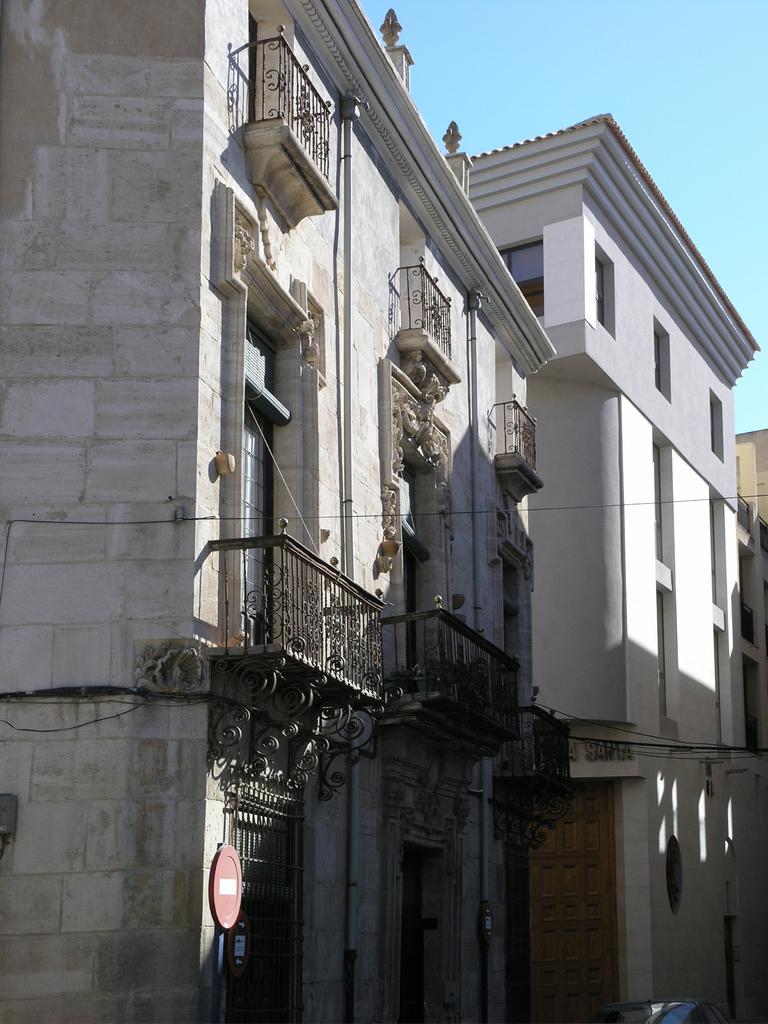How would you summarize this image in a sentence or two? In this image there are buildings, for that buildings there are windows, that windows are covered with grills. 